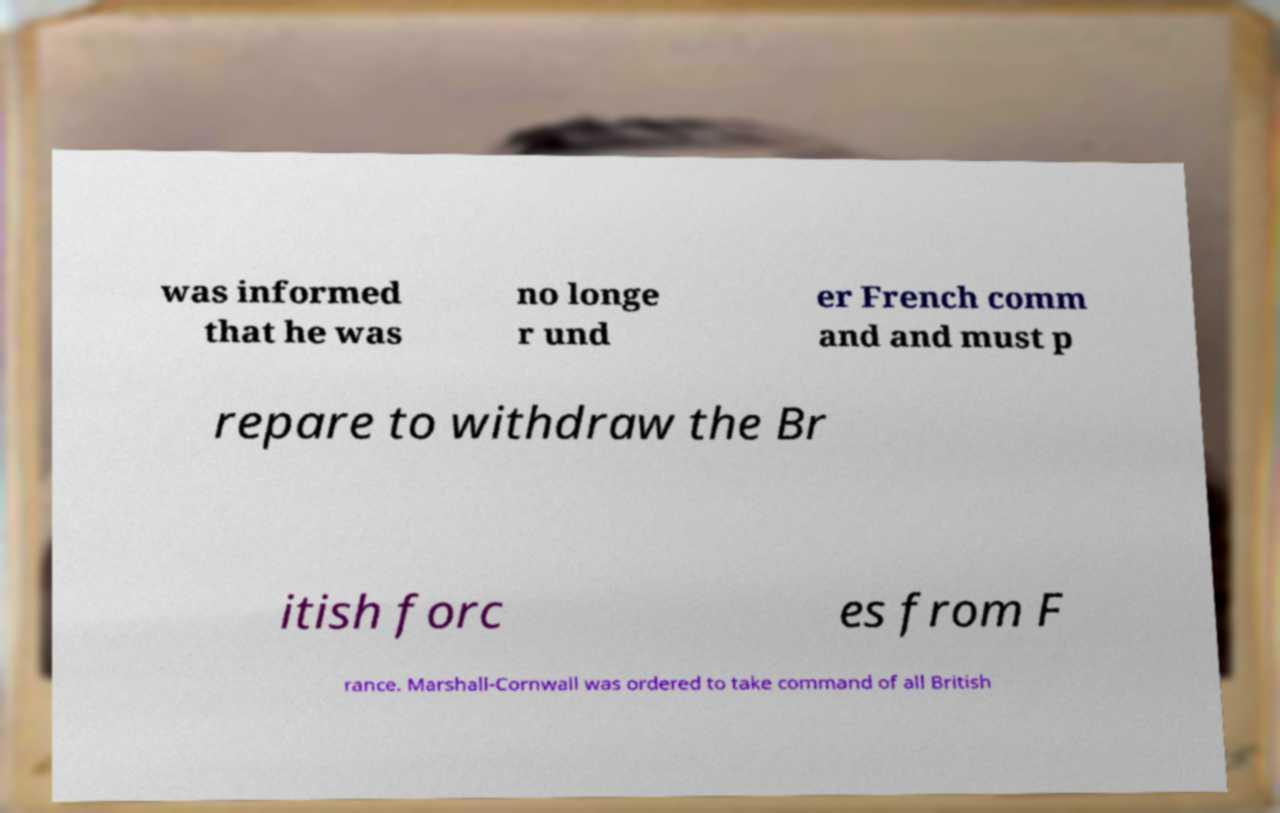I need the written content from this picture converted into text. Can you do that? was informed that he was no longe r und er French comm and and must p repare to withdraw the Br itish forc es from F rance. Marshall-Cornwall was ordered to take command of all British 